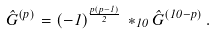<formula> <loc_0><loc_0><loc_500><loc_500>\hat { G } ^ { ( p ) } = ( - 1 ) ^ { \frac { p ( p - 1 ) } { 2 } } \, * _ { 1 0 } \hat { G } ^ { ( 1 0 - p ) } \, .</formula> 